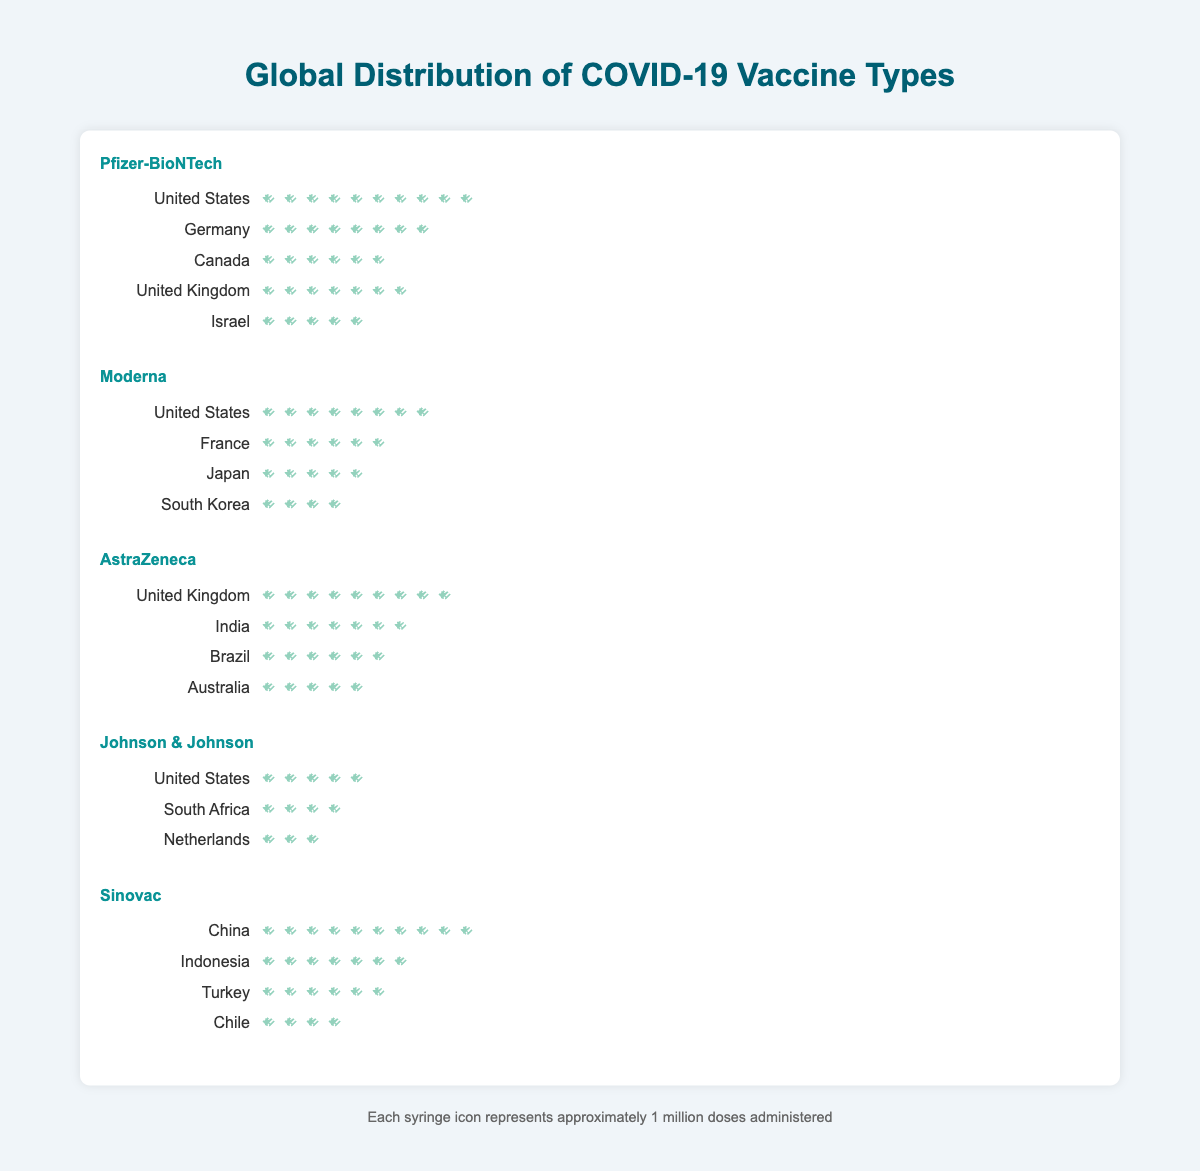What's the most commonly administered vaccine type in the United States? To determine this, we look at the syringe icons representing the count for each vaccine type in the United States. Pfizer-BioNTech has 10 icons, Moderna has 8, AstraZeneca has 0, Johnson & Johnson has 5 and Sinovac has 0. Therefore, Pfizer-BioNTech is the most commonly administered.
Answer: Pfizer-BioNTech Which country has the highest count for Sinovac? We examine the Sinovac row for the count in each country. China has 10 syringes, Indonesia has 7, Turkey has 6, and Chile has 4, making China the country with the highest count for Sinovac.
Answer: China What's the combined count of Pfizer-BioNTech and Moderna vaccines in the United States? We add the counts of Pfizer-BioNTech and Moderna in the United States. Pfizer-BioNTech count is 10, and Moderna count is 8. Summing these gives 10 + 8 = 18.
Answer: 18 How many countries have administered the Moderna vaccine? We count the number of different countries listed under Moderna. They are the United States, France, Japan, and South Korea, making a total of 4 countries.
Answer: 4 Which vaccine type has been administered in the most countries? We compare the number of countries for each vaccine type: Pfizer-BioNTech (5), Moderna (4), AstraZeneca (4), Johnson & Johnson (3), and Sinovac (4). Pfizer-BioNTech is administered in the most countries.
Answer: Pfizer-BioNTech Which country has the highest number of doses for AstraZeneca? By examining the AstraZeneca row, we see that the United Kingdom has 9 syringes, India has 7, Brazil has 6, and Australia has 5. The United Kingdom has the highest count.
Answer: United Kingdom Compare the number of countries where Pfizer-BioNTech and Johnson & Johnson are administered. Which has more? Pfizer-BioNTech is administered in 5 countries, while Johnson & Johnson is administered in 3 countries. Pfizer-BioNTech is administered in more countries.
Answer: Pfizer-BioNTech What is the total number of doses for Johnson & Johnson across all countries? We summate the counts for Johnson & Johnson across the listed countries. The United States has 5, South Africa has 4, and Netherlands has 3. Summing these gives 5 + 4 + 3 = 12.
Answer: 12 Which vaccine type has the least global distribution by the number of countries? We compare the number of countries for each vaccine type: Pfizer-BioNTech (5), Moderna (4), AstraZeneca (4), Johnson & Johnson (3), and Sinovac (4). Johnson & Johnson is administered in the least number of countries.
Answer: Johnson & Johnson 